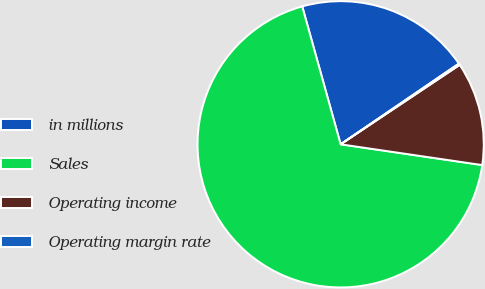<chart> <loc_0><loc_0><loc_500><loc_500><pie_chart><fcel>in millions<fcel>Sales<fcel>Operating income<fcel>Operating margin rate<nl><fcel>19.79%<fcel>68.36%<fcel>11.68%<fcel>0.17%<nl></chart> 